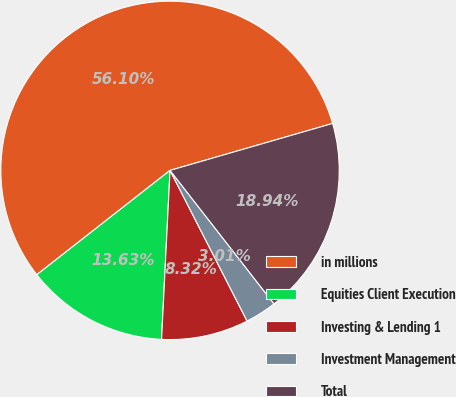Convert chart to OTSL. <chart><loc_0><loc_0><loc_500><loc_500><pie_chart><fcel>in millions<fcel>Equities Client Execution<fcel>Investing & Lending 1<fcel>Investment Management<fcel>Total<nl><fcel>56.1%<fcel>13.63%<fcel>8.32%<fcel>3.01%<fcel>18.94%<nl></chart> 